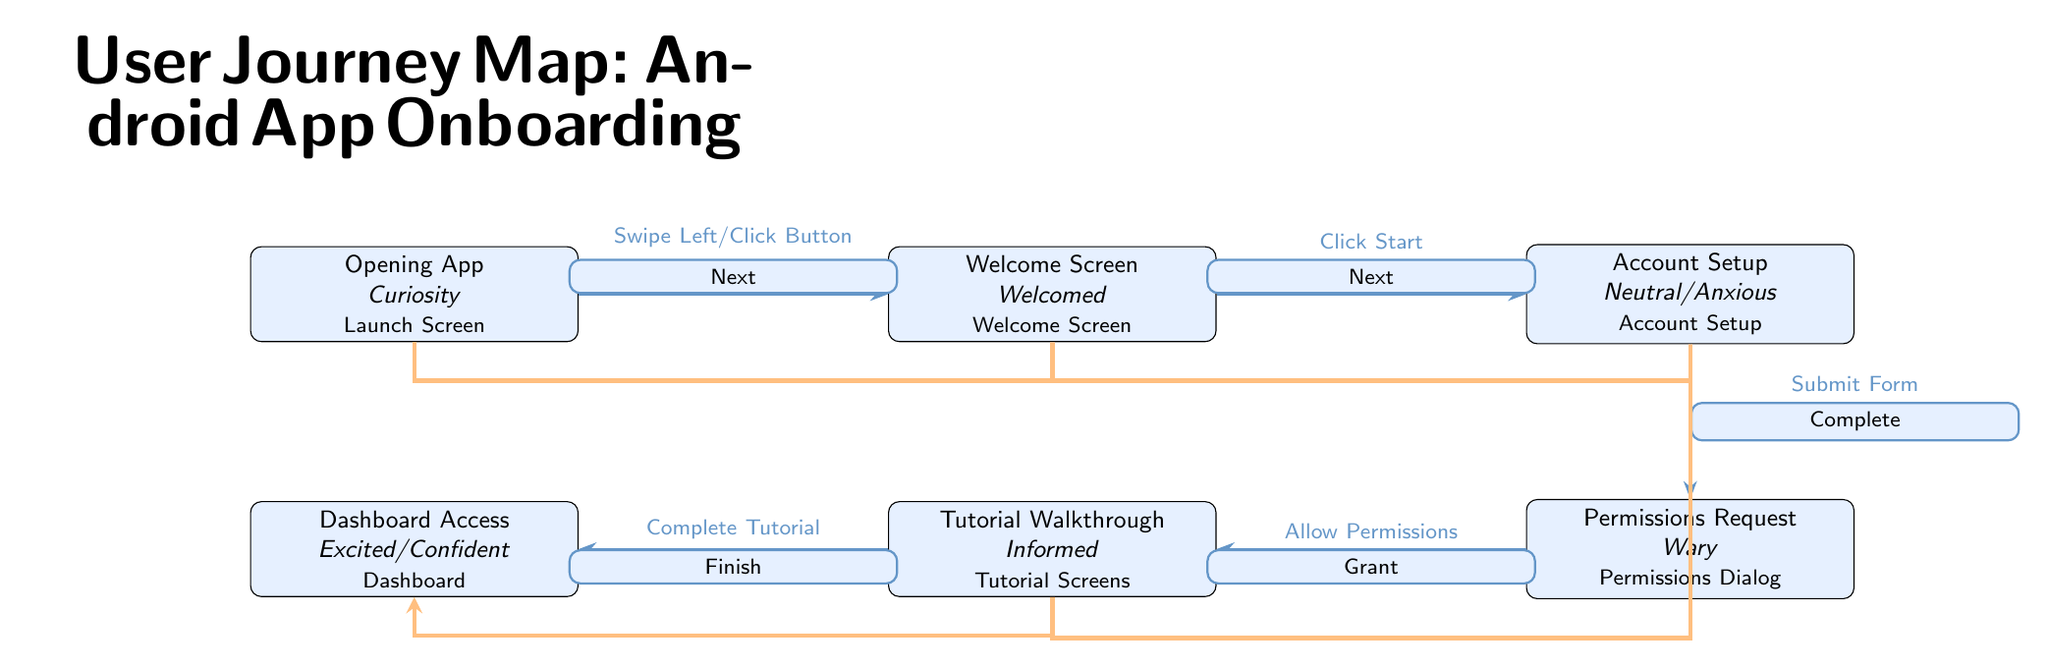What's the first node in the user journey? The first node in the user journey is indicated at the leftmost part of the diagram, labeled as "Opening App."
Answer: Opening App What is the user emotion associated with the "Permissions Request" node? The user emotion associated with the "Permissions Request" node is stated directly beneath the node, which is "Wary."
Answer: Wary How many total nodes are in the user journey map? By counting the individual elements presented in the diagram, there are six nodes representing various stages of the onboarding process.
Answer: 6 What action leads from the "Tutorial Walkthrough" to the "Dashboard Access"? The action leading from the "Tutorial Walkthrough" to the "Dashboard Access" is labeled as "Finish," which is the final action to complete the tutorial.
Answer: Finish Which node follows the "Account Setup"? The node that follows the "Account Setup" is described in the diagram as "Permissions Request," and it is positioned directly below it.
Answer: Permissions Request What is the last user emotion shown in the journey? The last user emotion shown in the journey is positioned beneath the last node, "Dashboard Access," and is noted as "Excited/Confident."
Answer: Excited/Confident What type of user interface is represented in the "Welcome Screen" node? The "Welcome Screen" node specifically refers to the type of interface, which is clearly labeled as "Welcome Screen."
Answer: Welcome Screen Which edge transition indicates the completion of the account setup? The edge transition that indicates the completion of the account setup is labeled as "Complete," which connects the "Account Setup" node to the subsequent "Permissions Request" node.
Answer: Complete 